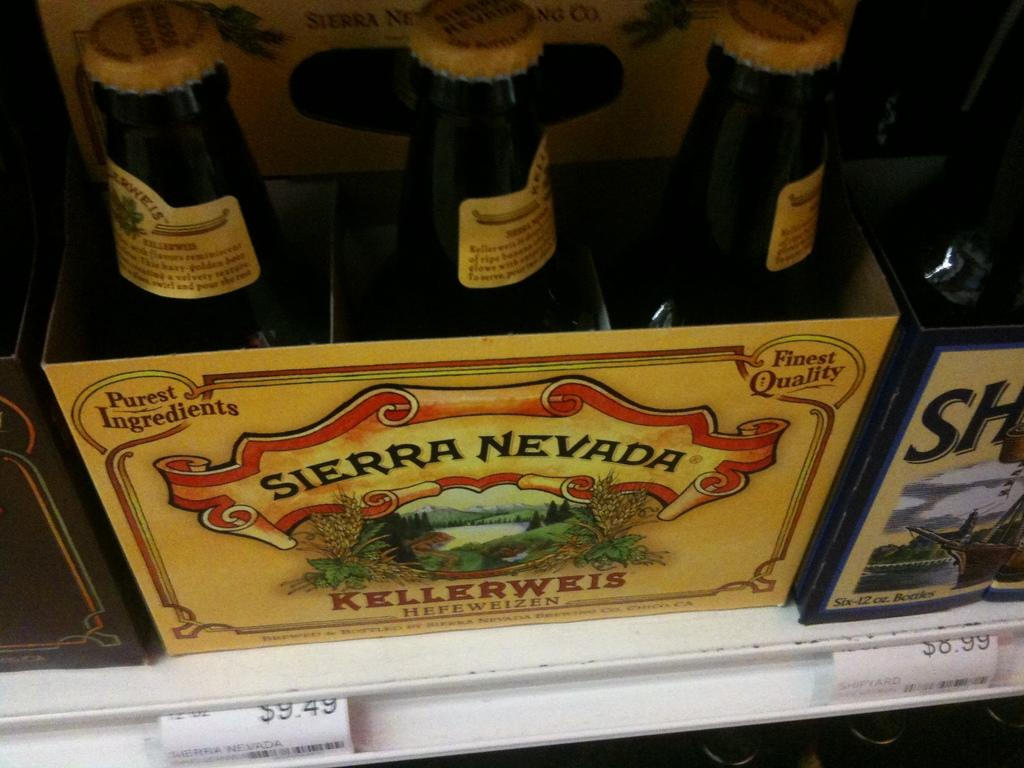<image>
Present a compact description of the photo's key features. the name sierra nevada that is on a drink 